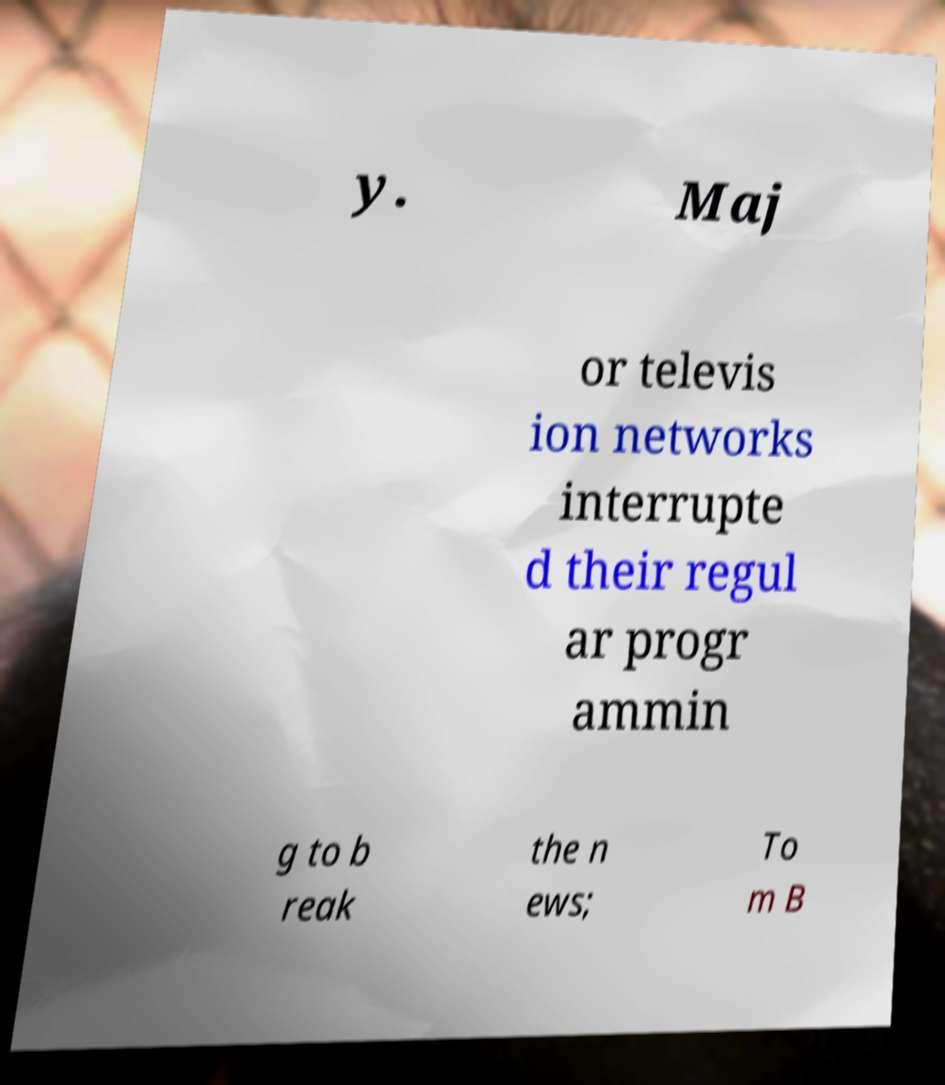I need the written content from this picture converted into text. Can you do that? y. Maj or televis ion networks interrupte d their regul ar progr ammin g to b reak the n ews; To m B 